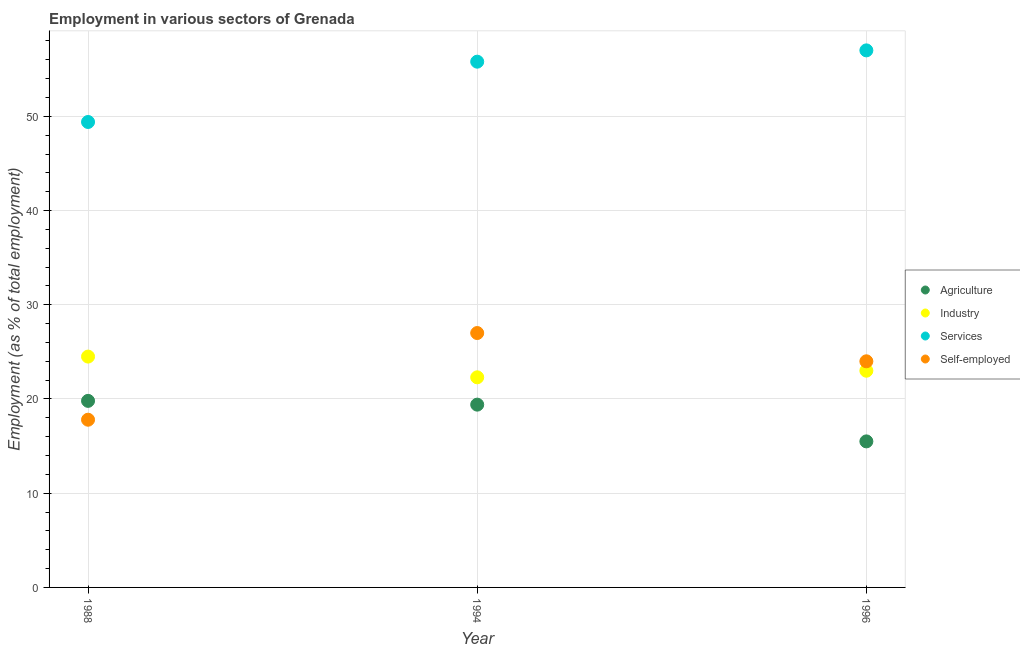What is the percentage of workers in services in 1996?
Provide a short and direct response. 57. Across all years, what is the maximum percentage of workers in agriculture?
Your answer should be very brief. 19.8. What is the total percentage of workers in services in the graph?
Your answer should be compact. 162.2. What is the difference between the percentage of workers in agriculture in 1994 and that in 1996?
Provide a short and direct response. 3.9. What is the difference between the percentage of workers in agriculture in 1994 and the percentage of self employed workers in 1988?
Your answer should be compact. 1.6. What is the average percentage of workers in services per year?
Offer a terse response. 54.07. In the year 1994, what is the difference between the percentage of workers in services and percentage of workers in agriculture?
Keep it short and to the point. 36.4. What is the ratio of the percentage of workers in agriculture in 1988 to that in 1996?
Offer a terse response. 1.28. Is the percentage of workers in agriculture in 1988 less than that in 1996?
Keep it short and to the point. No. Is the difference between the percentage of self employed workers in 1988 and 1994 greater than the difference between the percentage of workers in services in 1988 and 1994?
Your response must be concise. No. What is the difference between the highest and the second highest percentage of workers in industry?
Provide a succinct answer. 1.5. What is the difference between the highest and the lowest percentage of workers in services?
Make the answer very short. 7.6. In how many years, is the percentage of workers in services greater than the average percentage of workers in services taken over all years?
Make the answer very short. 2. Is the sum of the percentage of workers in agriculture in 1994 and 1996 greater than the maximum percentage of workers in industry across all years?
Offer a very short reply. Yes. Is it the case that in every year, the sum of the percentage of workers in agriculture and percentage of workers in industry is greater than the percentage of workers in services?
Give a very brief answer. No. Does the percentage of workers in agriculture monotonically increase over the years?
Make the answer very short. No. Is the percentage of workers in industry strictly greater than the percentage of workers in services over the years?
Your answer should be compact. No. How many dotlines are there?
Offer a very short reply. 4. What is the difference between two consecutive major ticks on the Y-axis?
Give a very brief answer. 10. Does the graph contain grids?
Provide a short and direct response. Yes. How many legend labels are there?
Your answer should be very brief. 4. How are the legend labels stacked?
Give a very brief answer. Vertical. What is the title of the graph?
Provide a short and direct response. Employment in various sectors of Grenada. What is the label or title of the X-axis?
Provide a short and direct response. Year. What is the label or title of the Y-axis?
Keep it short and to the point. Employment (as % of total employment). What is the Employment (as % of total employment) in Agriculture in 1988?
Offer a very short reply. 19.8. What is the Employment (as % of total employment) in Services in 1988?
Give a very brief answer. 49.4. What is the Employment (as % of total employment) of Self-employed in 1988?
Your answer should be very brief. 17.8. What is the Employment (as % of total employment) of Agriculture in 1994?
Your response must be concise. 19.4. What is the Employment (as % of total employment) in Industry in 1994?
Your answer should be very brief. 22.3. What is the Employment (as % of total employment) in Services in 1994?
Give a very brief answer. 55.8. What is the Employment (as % of total employment) of Self-employed in 1994?
Provide a succinct answer. 27. What is the Employment (as % of total employment) in Self-employed in 1996?
Offer a terse response. 24. Across all years, what is the maximum Employment (as % of total employment) of Agriculture?
Provide a succinct answer. 19.8. Across all years, what is the minimum Employment (as % of total employment) of Agriculture?
Ensure brevity in your answer.  15.5. Across all years, what is the minimum Employment (as % of total employment) in Industry?
Provide a short and direct response. 22.3. Across all years, what is the minimum Employment (as % of total employment) of Services?
Provide a succinct answer. 49.4. Across all years, what is the minimum Employment (as % of total employment) in Self-employed?
Your answer should be compact. 17.8. What is the total Employment (as % of total employment) of Agriculture in the graph?
Make the answer very short. 54.7. What is the total Employment (as % of total employment) in Industry in the graph?
Ensure brevity in your answer.  69.8. What is the total Employment (as % of total employment) in Services in the graph?
Offer a very short reply. 162.2. What is the total Employment (as % of total employment) in Self-employed in the graph?
Offer a very short reply. 68.8. What is the difference between the Employment (as % of total employment) of Services in 1988 and that in 1994?
Offer a very short reply. -6.4. What is the difference between the Employment (as % of total employment) in Industry in 1988 and that in 1996?
Ensure brevity in your answer.  1.5. What is the difference between the Employment (as % of total employment) in Self-employed in 1988 and that in 1996?
Your answer should be compact. -6.2. What is the difference between the Employment (as % of total employment) in Industry in 1994 and that in 1996?
Give a very brief answer. -0.7. What is the difference between the Employment (as % of total employment) in Services in 1994 and that in 1996?
Ensure brevity in your answer.  -1.2. What is the difference between the Employment (as % of total employment) in Self-employed in 1994 and that in 1996?
Your answer should be compact. 3. What is the difference between the Employment (as % of total employment) in Agriculture in 1988 and the Employment (as % of total employment) in Services in 1994?
Keep it short and to the point. -36. What is the difference between the Employment (as % of total employment) of Agriculture in 1988 and the Employment (as % of total employment) of Self-employed in 1994?
Provide a succinct answer. -7.2. What is the difference between the Employment (as % of total employment) of Industry in 1988 and the Employment (as % of total employment) of Services in 1994?
Your response must be concise. -31.3. What is the difference between the Employment (as % of total employment) of Industry in 1988 and the Employment (as % of total employment) of Self-employed in 1994?
Give a very brief answer. -2.5. What is the difference between the Employment (as % of total employment) in Services in 1988 and the Employment (as % of total employment) in Self-employed in 1994?
Give a very brief answer. 22.4. What is the difference between the Employment (as % of total employment) of Agriculture in 1988 and the Employment (as % of total employment) of Services in 1996?
Make the answer very short. -37.2. What is the difference between the Employment (as % of total employment) of Agriculture in 1988 and the Employment (as % of total employment) of Self-employed in 1996?
Make the answer very short. -4.2. What is the difference between the Employment (as % of total employment) of Industry in 1988 and the Employment (as % of total employment) of Services in 1996?
Your answer should be very brief. -32.5. What is the difference between the Employment (as % of total employment) in Services in 1988 and the Employment (as % of total employment) in Self-employed in 1996?
Your answer should be compact. 25.4. What is the difference between the Employment (as % of total employment) of Agriculture in 1994 and the Employment (as % of total employment) of Industry in 1996?
Offer a very short reply. -3.6. What is the difference between the Employment (as % of total employment) of Agriculture in 1994 and the Employment (as % of total employment) of Services in 1996?
Offer a terse response. -37.6. What is the difference between the Employment (as % of total employment) in Industry in 1994 and the Employment (as % of total employment) in Services in 1996?
Provide a short and direct response. -34.7. What is the difference between the Employment (as % of total employment) of Industry in 1994 and the Employment (as % of total employment) of Self-employed in 1996?
Give a very brief answer. -1.7. What is the difference between the Employment (as % of total employment) in Services in 1994 and the Employment (as % of total employment) in Self-employed in 1996?
Provide a short and direct response. 31.8. What is the average Employment (as % of total employment) in Agriculture per year?
Offer a very short reply. 18.23. What is the average Employment (as % of total employment) in Industry per year?
Provide a succinct answer. 23.27. What is the average Employment (as % of total employment) in Services per year?
Make the answer very short. 54.07. What is the average Employment (as % of total employment) in Self-employed per year?
Offer a terse response. 22.93. In the year 1988, what is the difference between the Employment (as % of total employment) of Agriculture and Employment (as % of total employment) of Services?
Give a very brief answer. -29.6. In the year 1988, what is the difference between the Employment (as % of total employment) in Agriculture and Employment (as % of total employment) in Self-employed?
Provide a short and direct response. 2. In the year 1988, what is the difference between the Employment (as % of total employment) of Industry and Employment (as % of total employment) of Services?
Your answer should be very brief. -24.9. In the year 1988, what is the difference between the Employment (as % of total employment) in Services and Employment (as % of total employment) in Self-employed?
Your answer should be very brief. 31.6. In the year 1994, what is the difference between the Employment (as % of total employment) of Agriculture and Employment (as % of total employment) of Services?
Keep it short and to the point. -36.4. In the year 1994, what is the difference between the Employment (as % of total employment) in Industry and Employment (as % of total employment) in Services?
Your answer should be compact. -33.5. In the year 1994, what is the difference between the Employment (as % of total employment) in Industry and Employment (as % of total employment) in Self-employed?
Provide a succinct answer. -4.7. In the year 1994, what is the difference between the Employment (as % of total employment) of Services and Employment (as % of total employment) of Self-employed?
Ensure brevity in your answer.  28.8. In the year 1996, what is the difference between the Employment (as % of total employment) in Agriculture and Employment (as % of total employment) in Industry?
Your answer should be compact. -7.5. In the year 1996, what is the difference between the Employment (as % of total employment) of Agriculture and Employment (as % of total employment) of Services?
Your answer should be very brief. -41.5. In the year 1996, what is the difference between the Employment (as % of total employment) in Agriculture and Employment (as % of total employment) in Self-employed?
Your answer should be compact. -8.5. In the year 1996, what is the difference between the Employment (as % of total employment) in Industry and Employment (as % of total employment) in Services?
Offer a terse response. -34. What is the ratio of the Employment (as % of total employment) in Agriculture in 1988 to that in 1994?
Provide a short and direct response. 1.02. What is the ratio of the Employment (as % of total employment) in Industry in 1988 to that in 1994?
Your response must be concise. 1.1. What is the ratio of the Employment (as % of total employment) of Services in 1988 to that in 1994?
Your response must be concise. 0.89. What is the ratio of the Employment (as % of total employment) in Self-employed in 1988 to that in 1994?
Make the answer very short. 0.66. What is the ratio of the Employment (as % of total employment) in Agriculture in 1988 to that in 1996?
Provide a short and direct response. 1.28. What is the ratio of the Employment (as % of total employment) in Industry in 1988 to that in 1996?
Offer a very short reply. 1.07. What is the ratio of the Employment (as % of total employment) of Services in 1988 to that in 1996?
Give a very brief answer. 0.87. What is the ratio of the Employment (as % of total employment) of Self-employed in 1988 to that in 1996?
Your response must be concise. 0.74. What is the ratio of the Employment (as % of total employment) of Agriculture in 1994 to that in 1996?
Your answer should be compact. 1.25. What is the ratio of the Employment (as % of total employment) of Industry in 1994 to that in 1996?
Provide a short and direct response. 0.97. What is the ratio of the Employment (as % of total employment) of Services in 1994 to that in 1996?
Give a very brief answer. 0.98. What is the difference between the highest and the second highest Employment (as % of total employment) of Agriculture?
Your response must be concise. 0.4. What is the difference between the highest and the second highest Employment (as % of total employment) of Services?
Make the answer very short. 1.2. What is the difference between the highest and the second highest Employment (as % of total employment) of Self-employed?
Offer a very short reply. 3. What is the difference between the highest and the lowest Employment (as % of total employment) of Agriculture?
Make the answer very short. 4.3. What is the difference between the highest and the lowest Employment (as % of total employment) of Industry?
Your answer should be very brief. 2.2. 